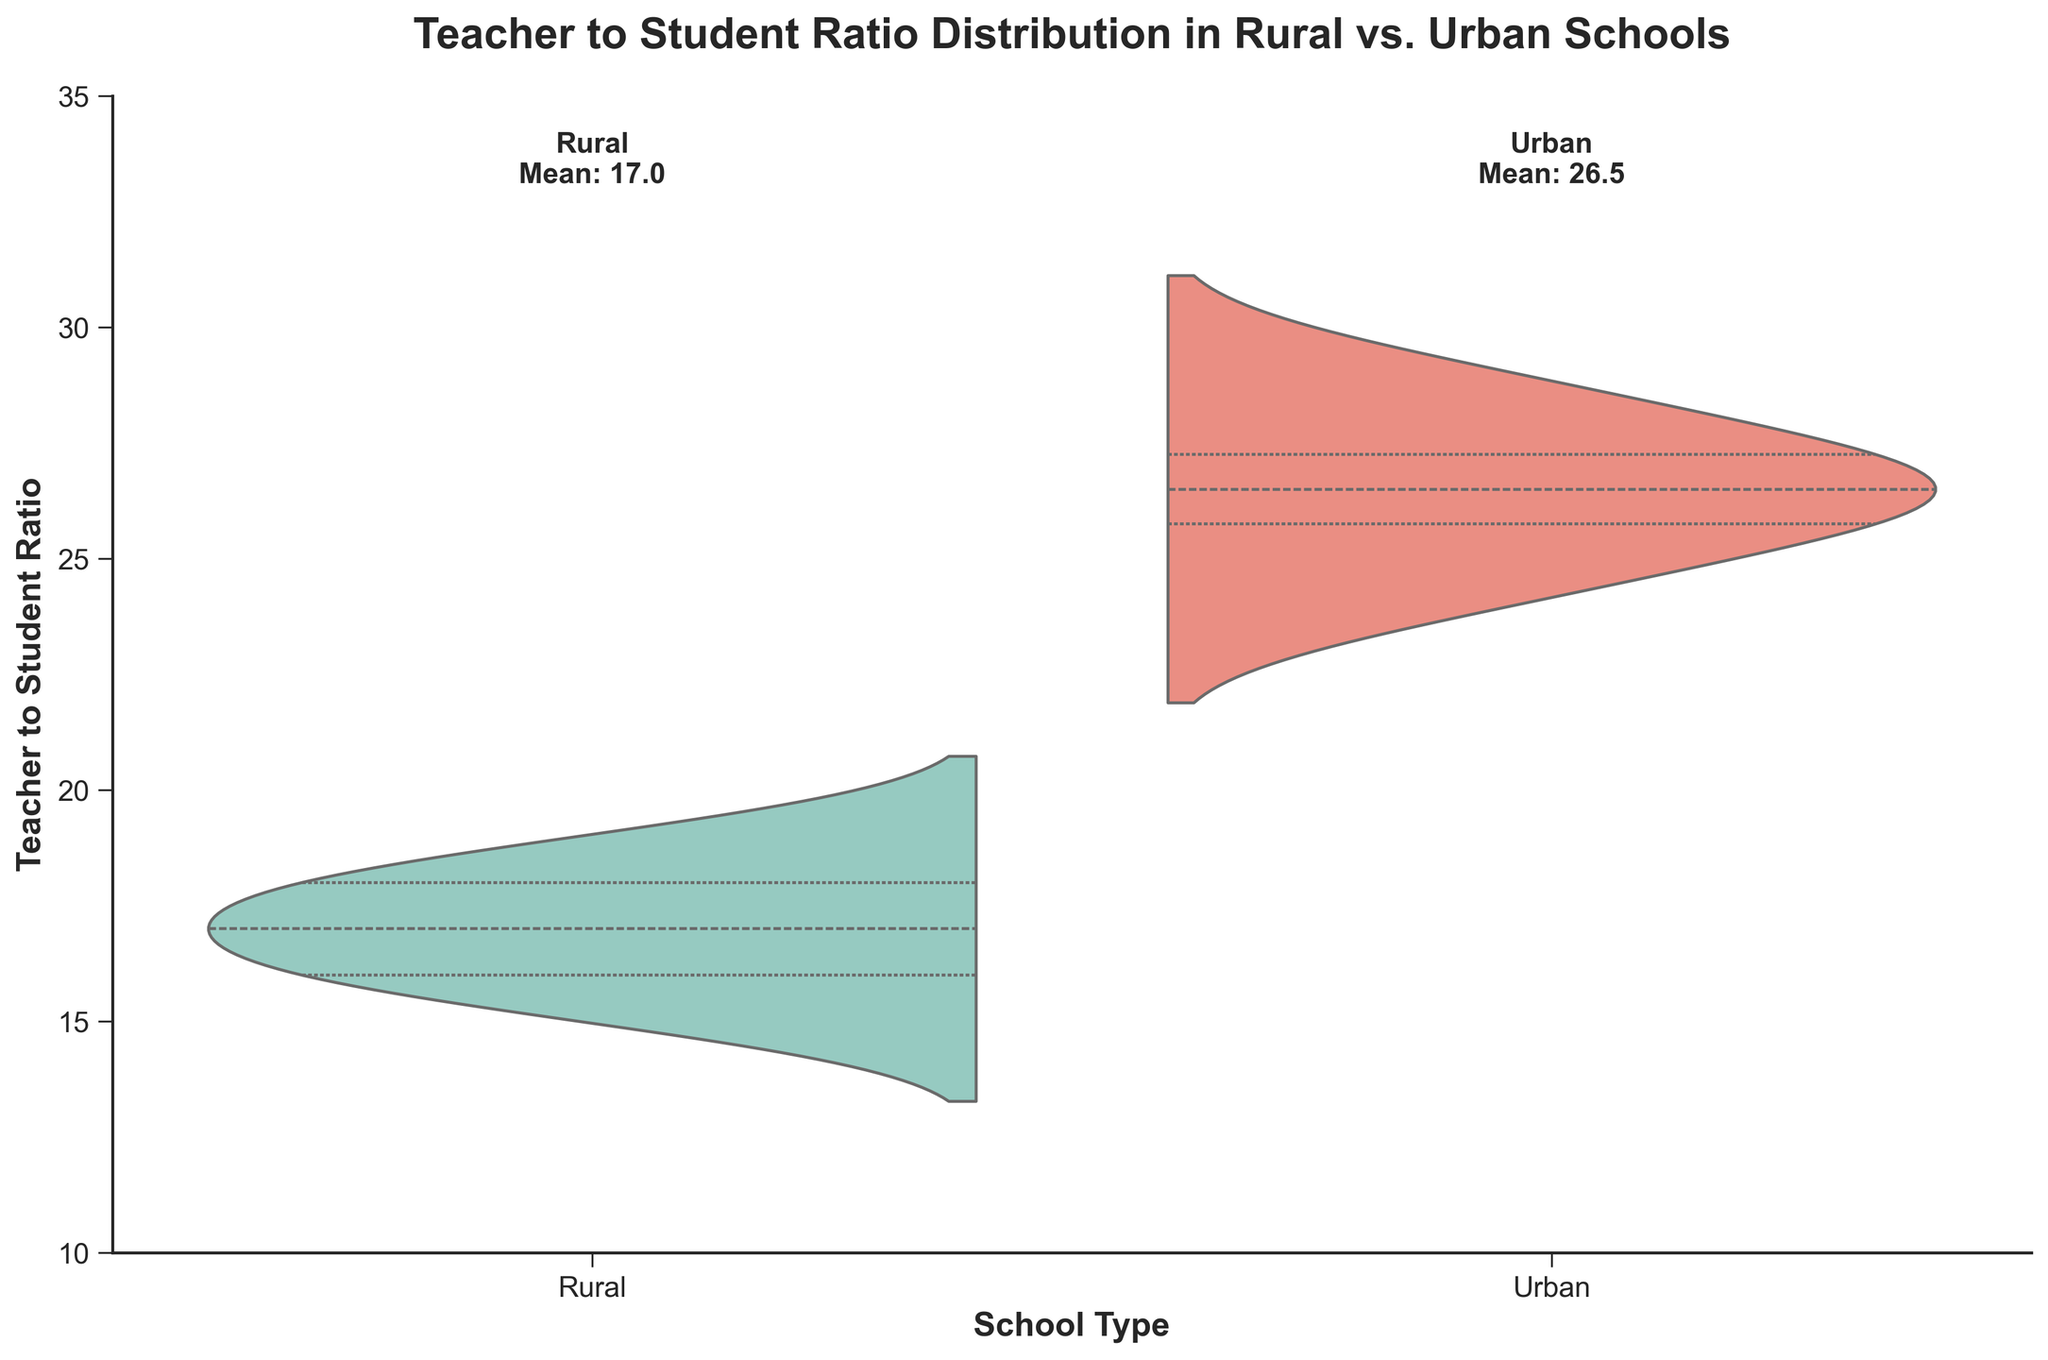What is the title of the chart? The title is usually found at the top of the chart and provides a summary of the information being displayed.
Answer: Teacher to Student Ratio Distribution in Rural vs. Urban Schools What is the average teacher to student ratio for rural schools shown on the chart? Look at the text near the top of the violin plot for the rural category; it provides the mean value.
Answer: 16.6 Which group, Rural or Urban, has a higher average teacher to student ratio? Compare the mean values annotated at the top of each violin plot. Urban schools have a mean of 26.5, whereas rural schools have a mean of 16.6.
Answer: Urban What is the median teacher to student ratio for rural schools? The median can be inferred from the thick white line in the middle of the violin plot; for rural schools, it falls around 17.
Answer: 17 Which school type shows a wider spread in teacher to student ratios? The width of each violin plot indicates the distribution. A wider plot suggests more variability in the data. Urban schools display a wider plot, indicating a larger spread.
Answer: Urban How does the maximum teacher to student ratio in Urban schools compare to that in Rural schools? Observing the top of the violin plots reveals that the maximum teacher to student ratio for Urban schools is around 29, while for Rural schools, it is approximately 19.
Answer: Urban has a higher maximum What is the range of the teacher-student ratio in rural schools? The range is calculated by subtracting the lowest ratio from the highest ratio. For rural schools, this is 19 - 15 = 4.
Answer: 4 Does any school type have a teacher to student ratio below 15? Look at the violin plots and check if there is any part of the plot extending below the value of 15 on the y-axis. The rural plot starts at 15, while the urban plot is above 15.
Answer: No Are there more schools with higher ratios in Urban or Rural settings? Examine the shape and distribution of the violin plots; urban schools have more data points at higher teacher-student ratios, indicating more schools with higher ratios.
Answer: Urban 